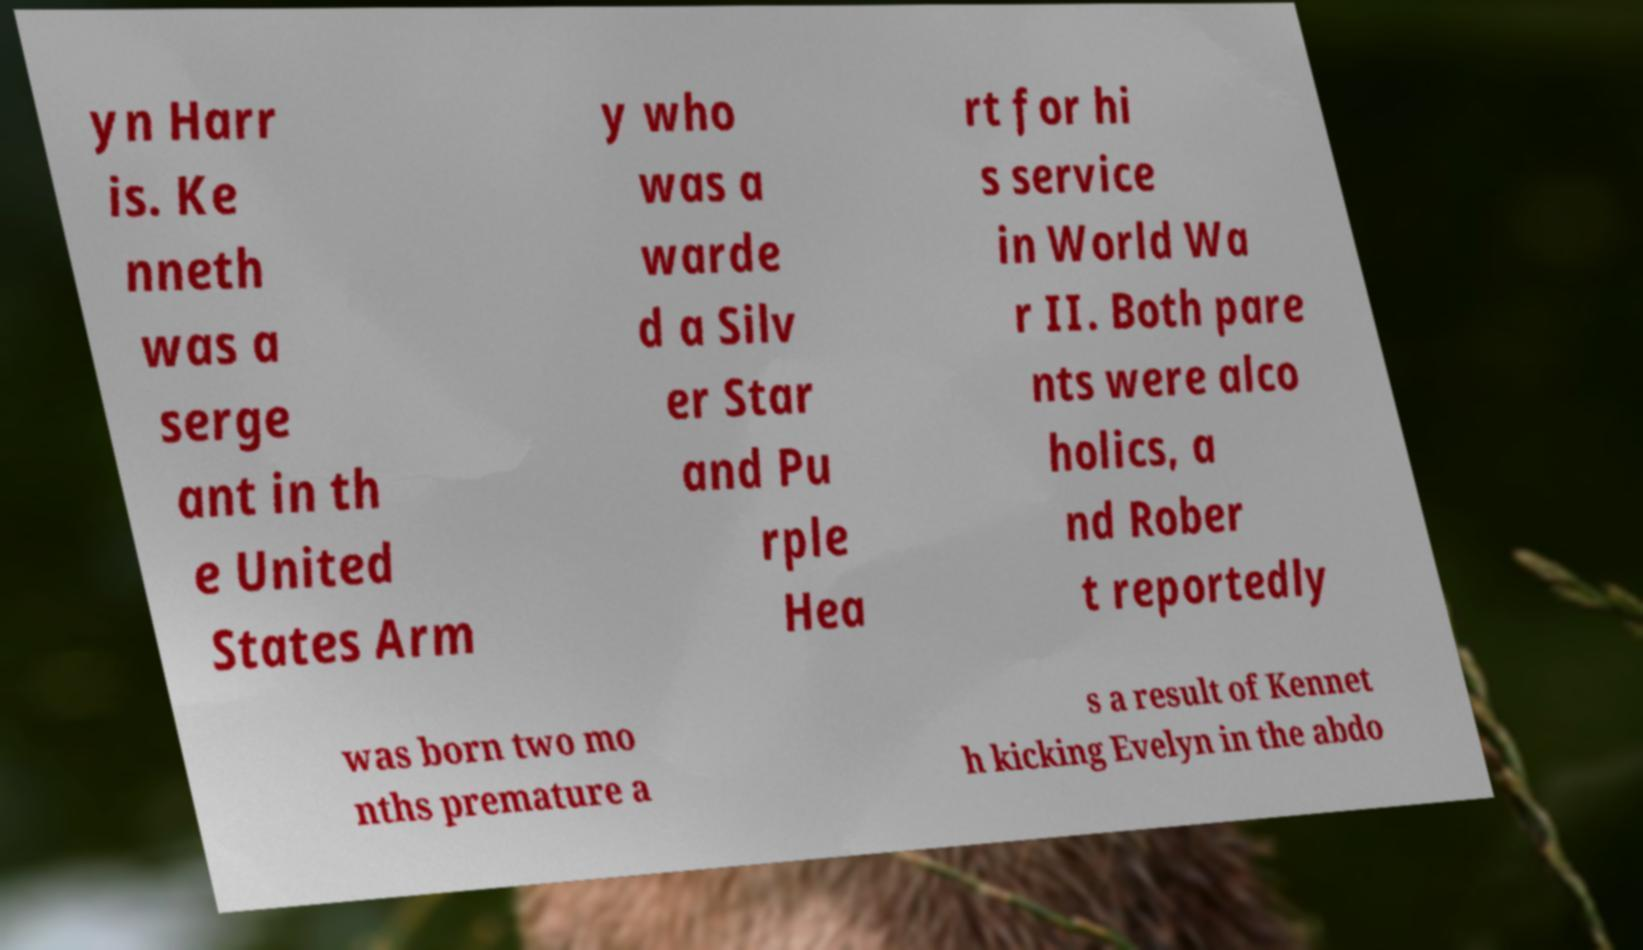There's text embedded in this image that I need extracted. Can you transcribe it verbatim? yn Harr is. Ke nneth was a serge ant in th e United States Arm y who was a warde d a Silv er Star and Pu rple Hea rt for hi s service in World Wa r II. Both pare nts were alco holics, a nd Rober t reportedly was born two mo nths premature a s a result of Kennet h kicking Evelyn in the abdo 